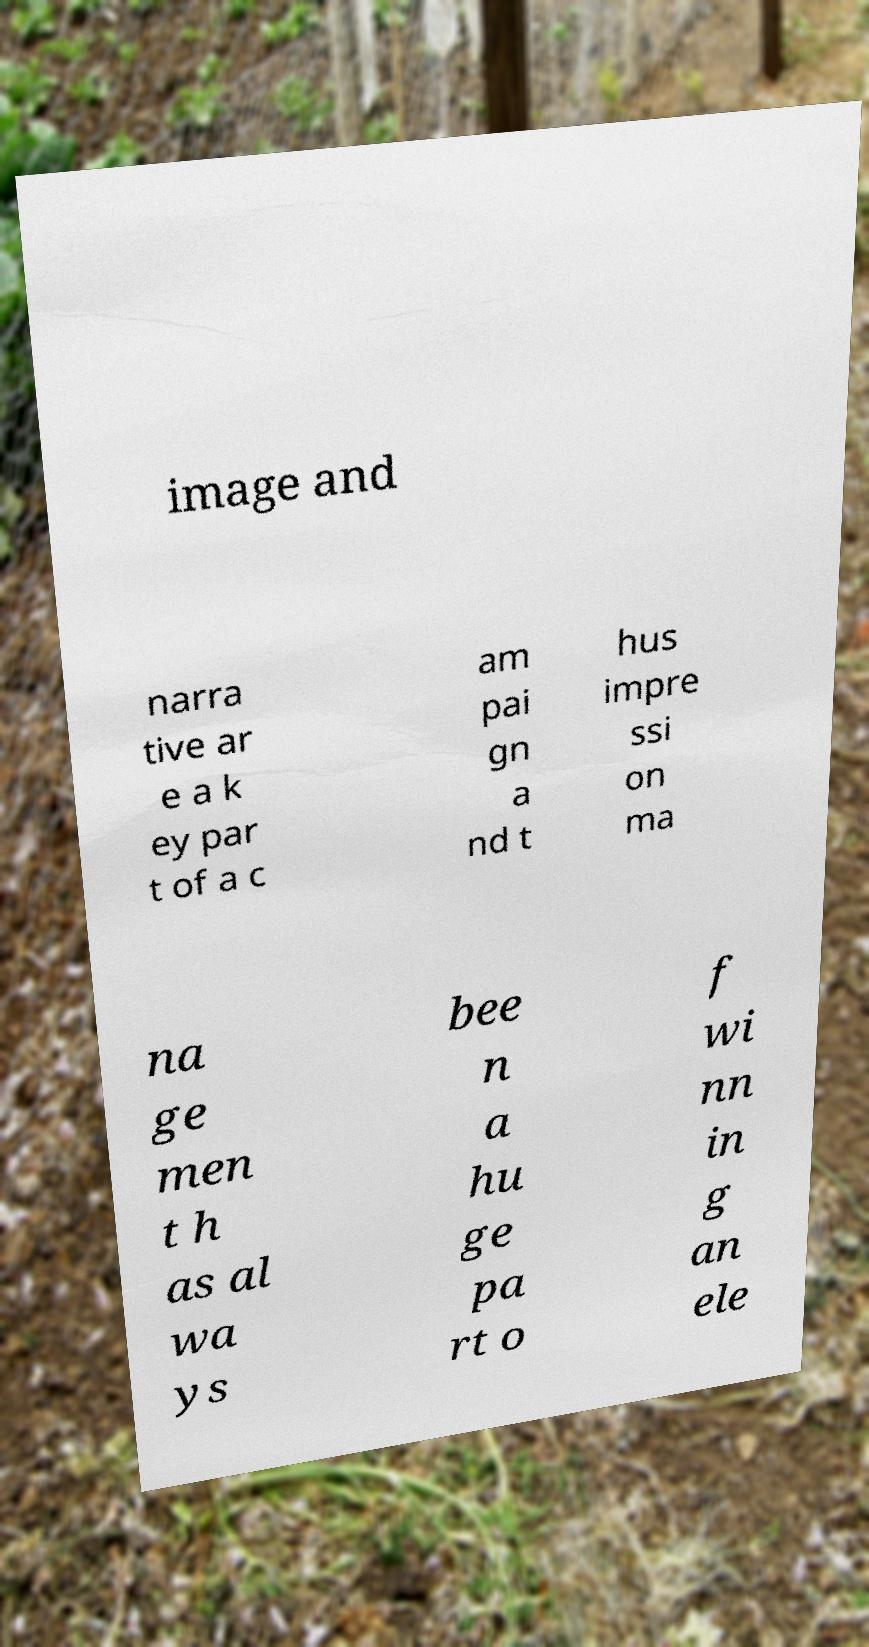There's text embedded in this image that I need extracted. Can you transcribe it verbatim? image and narra tive ar e a k ey par t of a c am pai gn a nd t hus impre ssi on ma na ge men t h as al wa ys bee n a hu ge pa rt o f wi nn in g an ele 